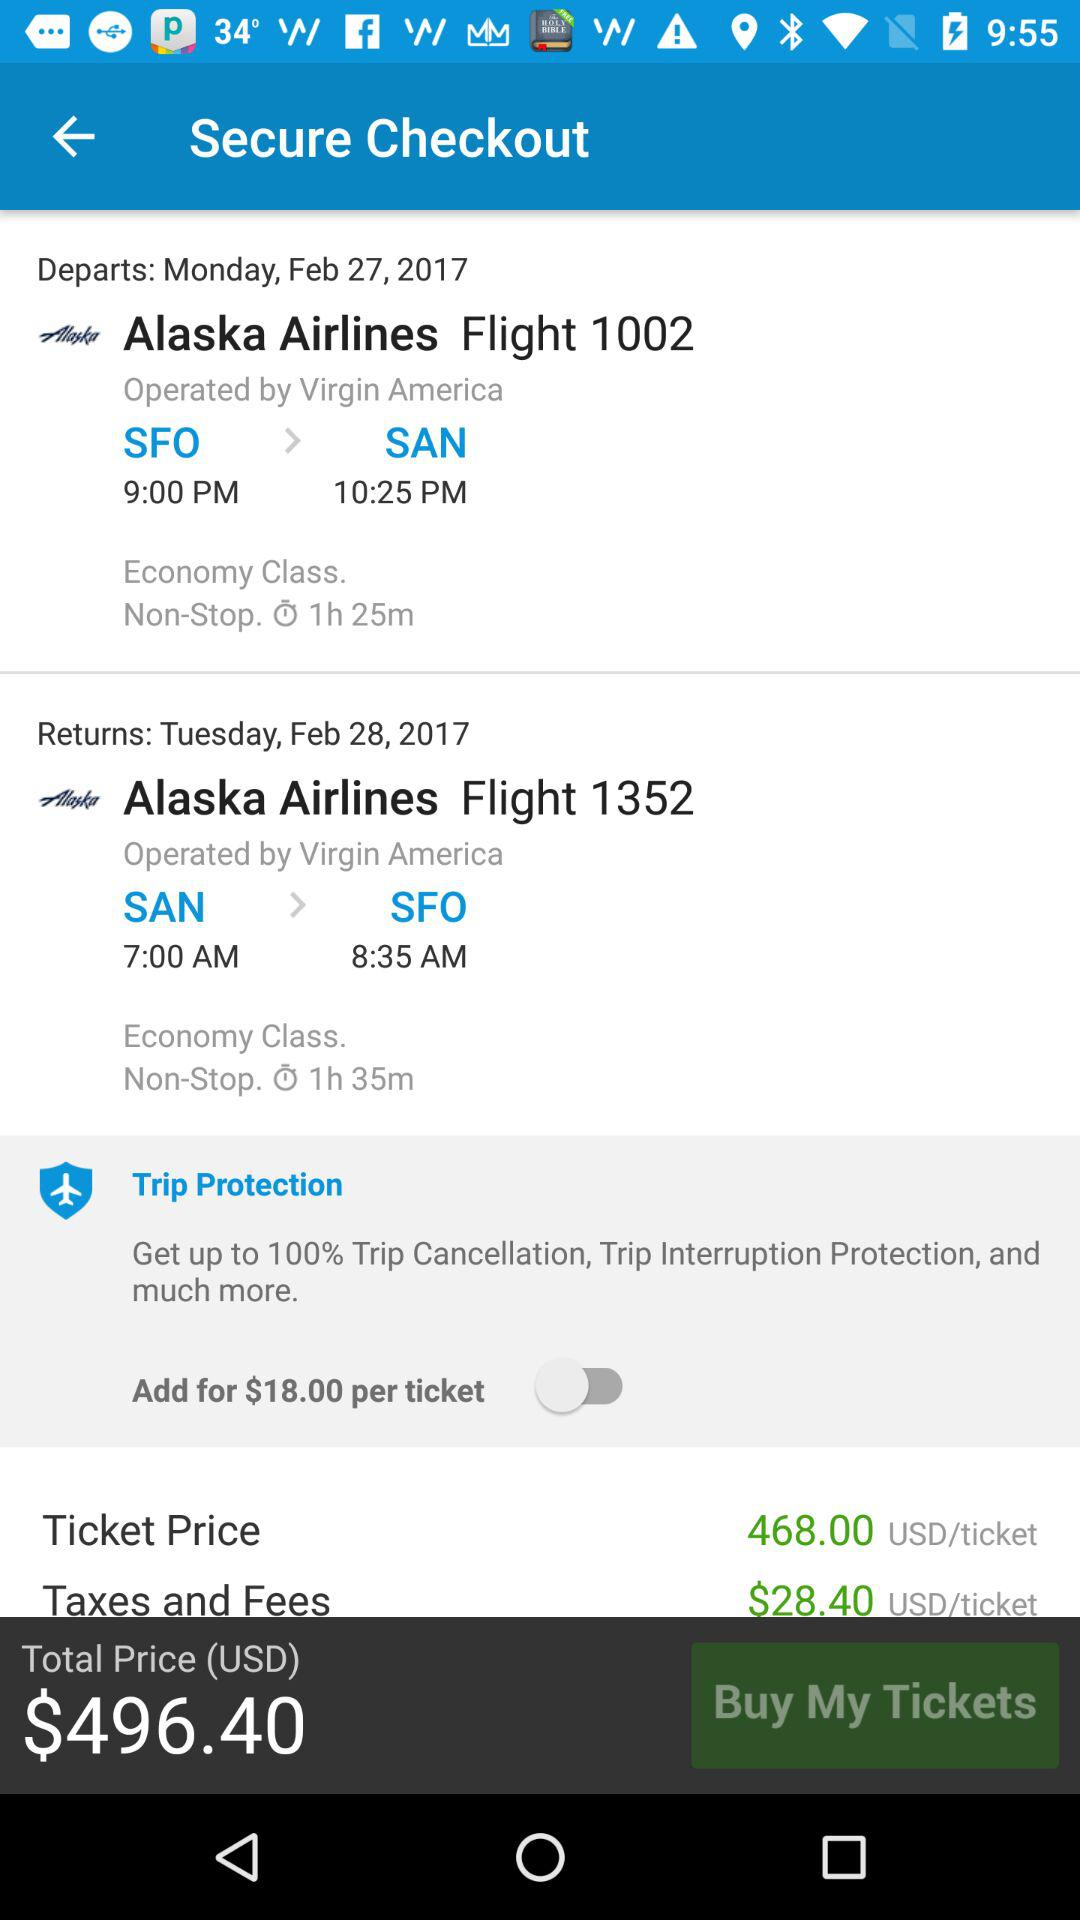What is the date and time of the return flight? The date and time of the return flight is Tuesday, February 28, 2017 at 7:00 AM. 